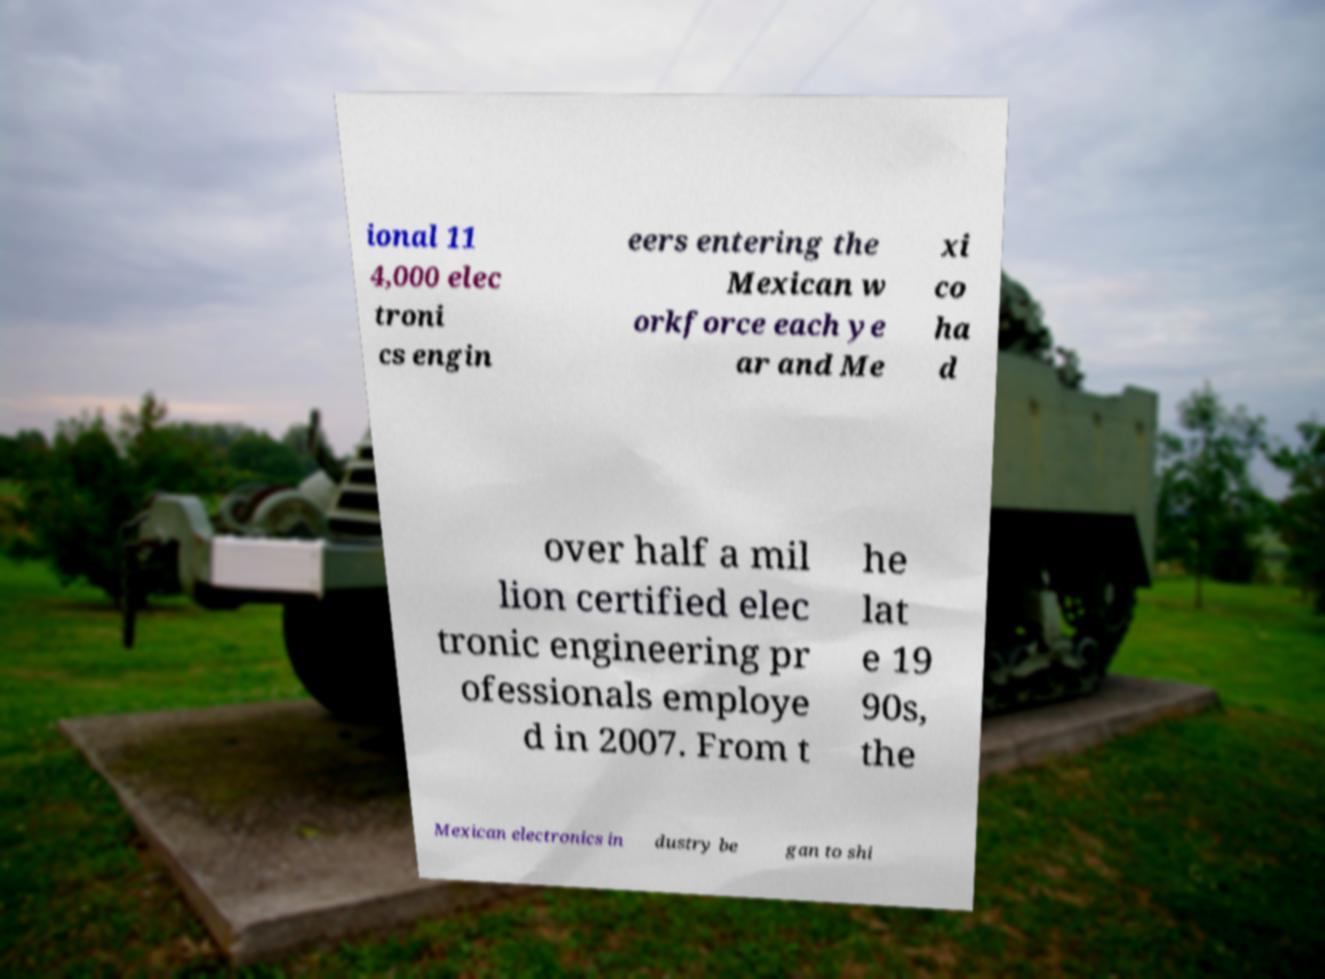What messages or text are displayed in this image? I need them in a readable, typed format. ional 11 4,000 elec troni cs engin eers entering the Mexican w orkforce each ye ar and Me xi co ha d over half a mil lion certified elec tronic engineering pr ofessionals employe d in 2007. From t he lat e 19 90s, the Mexican electronics in dustry be gan to shi 